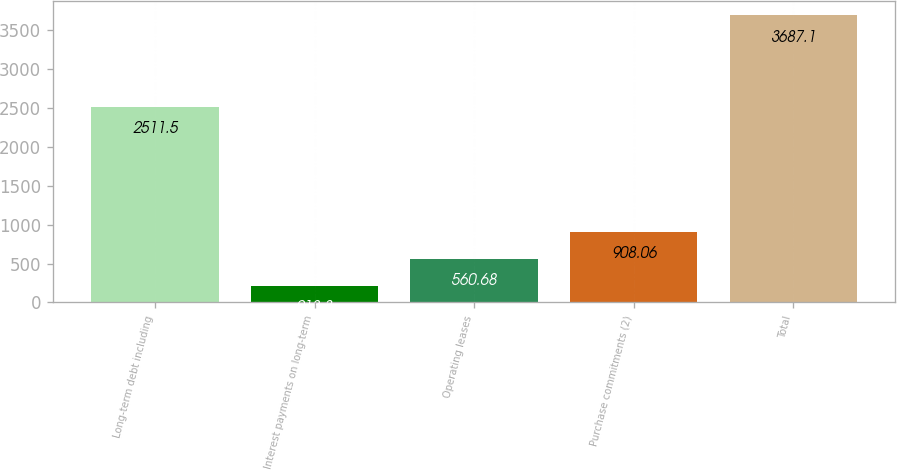<chart> <loc_0><loc_0><loc_500><loc_500><bar_chart><fcel>Long-term debt including<fcel>Interest payments on long-term<fcel>Operating leases<fcel>Purchase commitments (2)<fcel>Total<nl><fcel>2511.5<fcel>213.3<fcel>560.68<fcel>908.06<fcel>3687.1<nl></chart> 